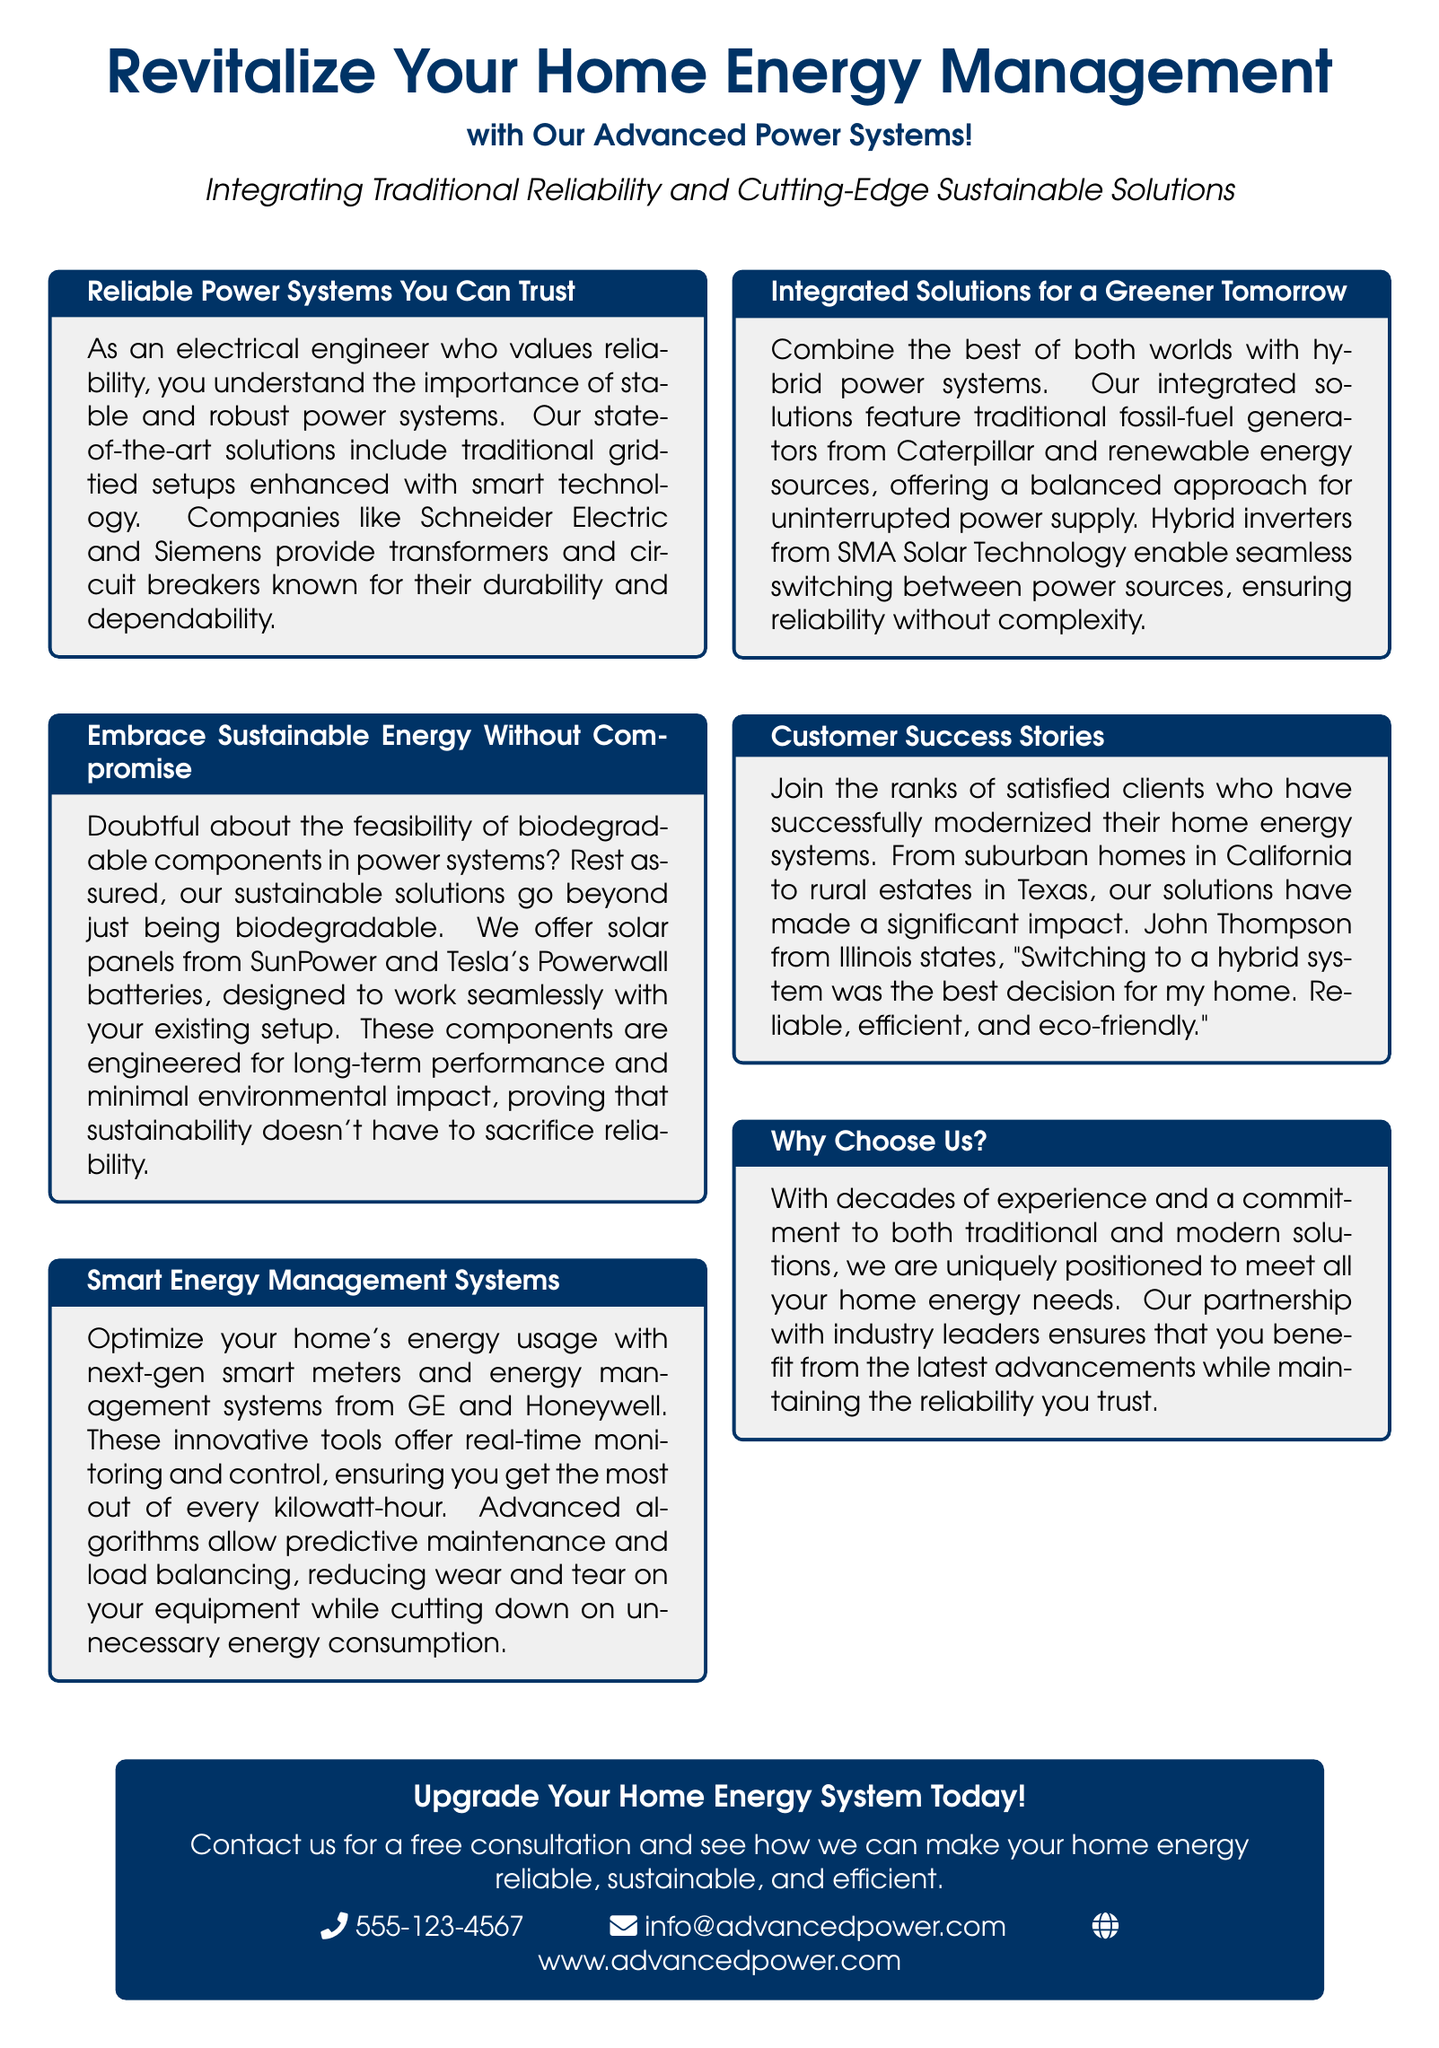What are the companies mentioned for reliable power systems? Companies like Schneider Electric and Siemens are referenced for their durable and dependable systems.
Answer: Schneider Electric and Siemens What technology is integrated with traditional power systems? The document states that traditional grid-tied setups are enhanced with smart technology.
Answer: Smart technology What sustainable solution is specifically mentioned in the advertisement? The advertisement highlights solar panels from SunPower and Tesla's Powerwall batteries.
Answer: Solar panels from SunPower and Tesla's Powerwall batteries What type of systems do GE and Honeywell provide? They provide next-gen smart meters and energy management systems for home energy usage optimization.
Answer: Smart meters and energy management systems What is the main benefit of hybrid power systems according to the document? Hybrid power systems offer a balanced approach for uninterrupted power supply.
Answer: Uninterrupted power supply What is a key feature of the hybrid inverters mentioned? They enable seamless switching between power sources.
Answer: Seamless switching How does John Thompson describe his experience with the hybrid system? He states that switching to a hybrid system was the best decision for his home.
Answer: The best decision for my home What is the primary focus of the advertisement? The focus is on revitalizing home energy management with advanced power systems.
Answer: Revitalizing home energy management What service does the advertisement promote at the end? The advertisement promotes a free consultation for upgrading home energy systems.
Answer: Free consultation 